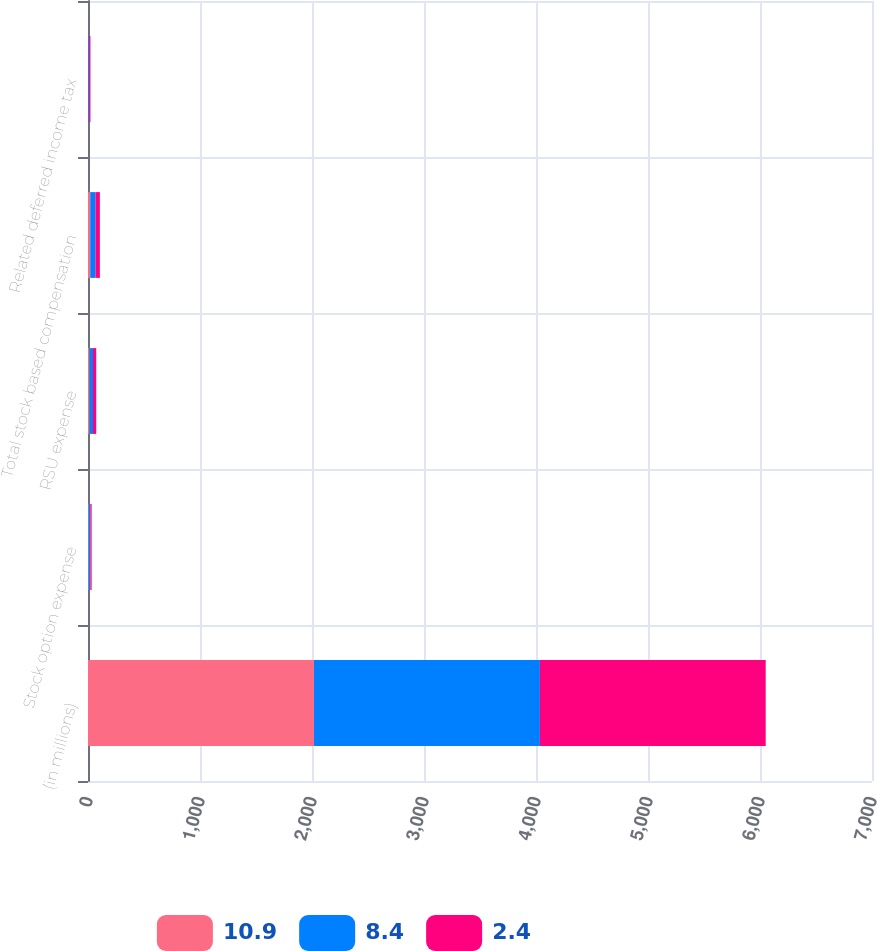Convert chart to OTSL. <chart><loc_0><loc_0><loc_500><loc_500><stacked_bar_chart><ecel><fcel>(in millions)<fcel>Stock option expense<fcel>RSU expense<fcel>Total stock based compensation<fcel>Related deferred income tax<nl><fcel>10.9<fcel>2018<fcel>6.6<fcel>13.2<fcel>19.8<fcel>2.4<nl><fcel>8.4<fcel>2017<fcel>15.4<fcel>31.2<fcel>46.6<fcel>8.4<nl><fcel>2.4<fcel>2016<fcel>10.6<fcel>29.1<fcel>39.7<fcel>10.9<nl></chart> 